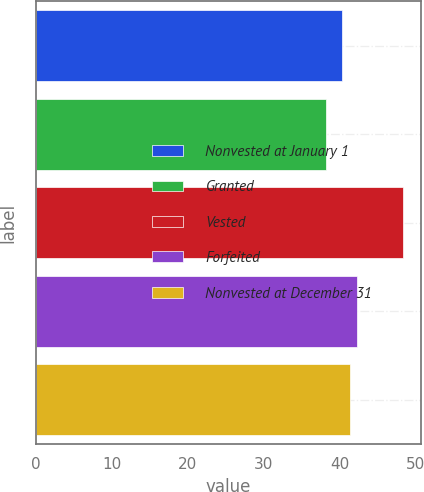Convert chart. <chart><loc_0><loc_0><loc_500><loc_500><bar_chart><fcel>Nonvested at January 1<fcel>Granted<fcel>Vested<fcel>Forfeited<fcel>Nonvested at December 31<nl><fcel>40.28<fcel>38.19<fcel>48.28<fcel>42.3<fcel>41.29<nl></chart> 